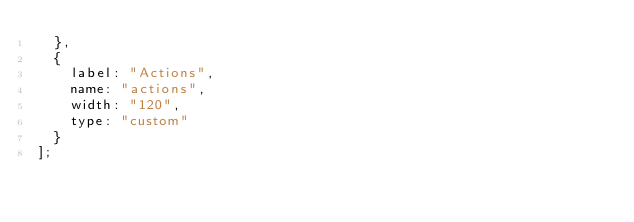<code> <loc_0><loc_0><loc_500><loc_500><_JavaScript_>  },
  {
    label: "Actions",
    name: "actions",
    width: "120",
    type: "custom"
  }
];
</code> 